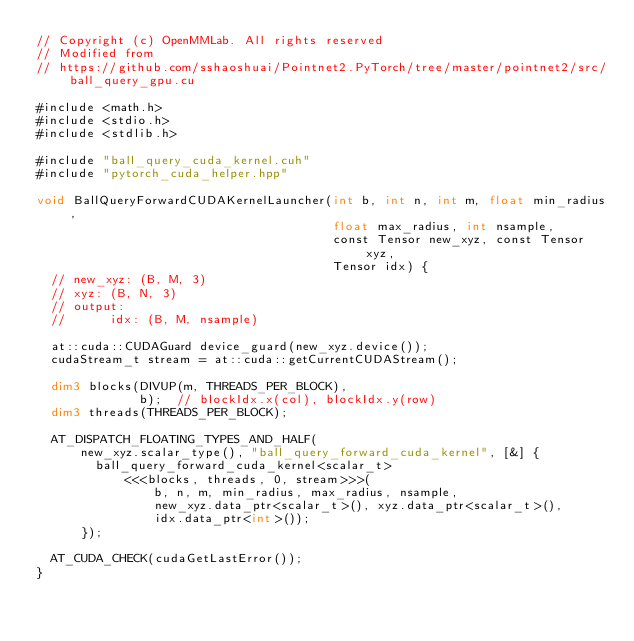Convert code to text. <code><loc_0><loc_0><loc_500><loc_500><_Cuda_>// Copyright (c) OpenMMLab. All rights reserved
// Modified from
// https://github.com/sshaoshuai/Pointnet2.PyTorch/tree/master/pointnet2/src/ball_query_gpu.cu

#include <math.h>
#include <stdio.h>
#include <stdlib.h>

#include "ball_query_cuda_kernel.cuh"
#include "pytorch_cuda_helper.hpp"

void BallQueryForwardCUDAKernelLauncher(int b, int n, int m, float min_radius,
                                        float max_radius, int nsample,
                                        const Tensor new_xyz, const Tensor xyz,
                                        Tensor idx) {
  // new_xyz: (B, M, 3)
  // xyz: (B, N, 3)
  // output:
  //      idx: (B, M, nsample)

  at::cuda::CUDAGuard device_guard(new_xyz.device());
  cudaStream_t stream = at::cuda::getCurrentCUDAStream();

  dim3 blocks(DIVUP(m, THREADS_PER_BLOCK),
              b);  // blockIdx.x(col), blockIdx.y(row)
  dim3 threads(THREADS_PER_BLOCK);

  AT_DISPATCH_FLOATING_TYPES_AND_HALF(
      new_xyz.scalar_type(), "ball_query_forward_cuda_kernel", [&] {
        ball_query_forward_cuda_kernel<scalar_t>
            <<<blocks, threads, 0, stream>>>(
                b, n, m, min_radius, max_radius, nsample,
                new_xyz.data_ptr<scalar_t>(), xyz.data_ptr<scalar_t>(),
                idx.data_ptr<int>());
      });

  AT_CUDA_CHECK(cudaGetLastError());
}
</code> 